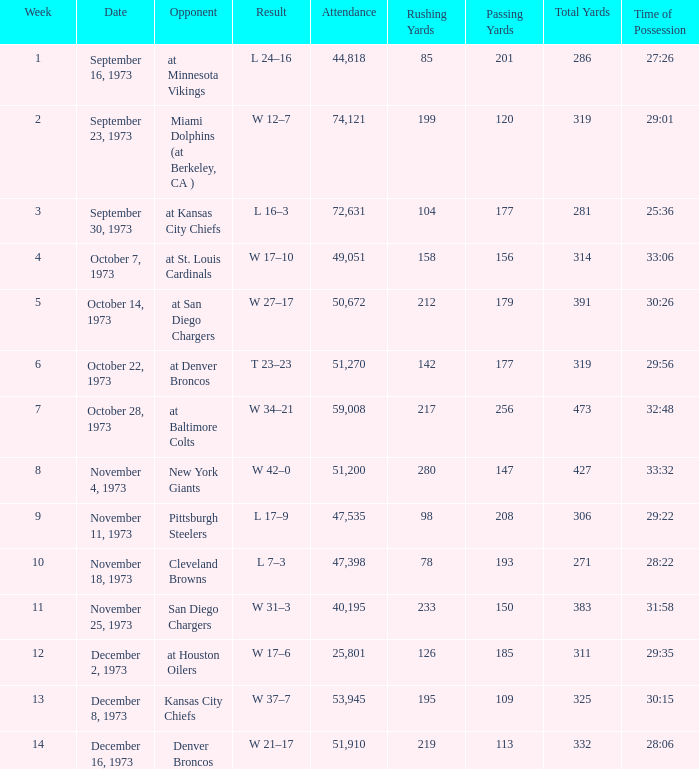What is the result later than week 13? W 21–17. 